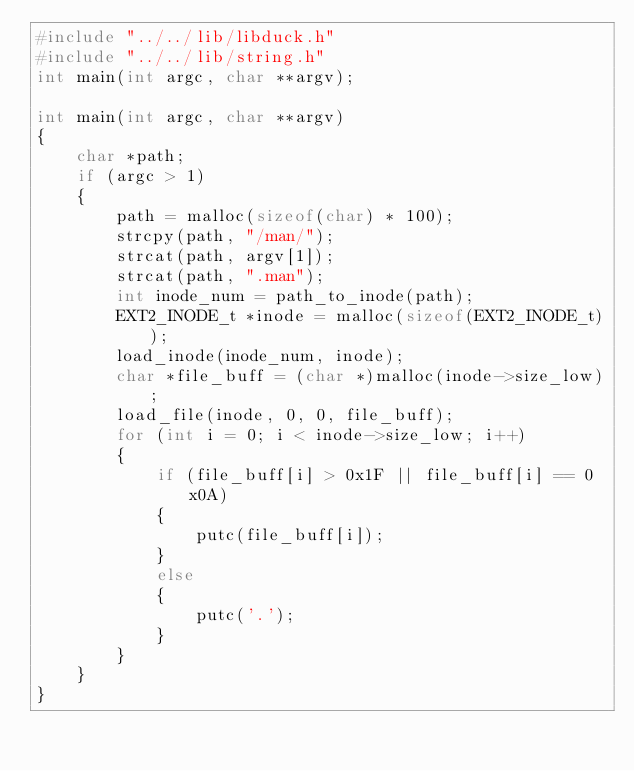<code> <loc_0><loc_0><loc_500><loc_500><_C_>#include "../../lib/libduck.h"
#include "../../lib/string.h"
int main(int argc, char **argv);

int main(int argc, char **argv)
{
    char *path;
    if (argc > 1)
    {
        path = malloc(sizeof(char) * 100);
        strcpy(path, "/man/");
        strcat(path, argv[1]);
        strcat(path, ".man");
        int inode_num = path_to_inode(path);
        EXT2_INODE_t *inode = malloc(sizeof(EXT2_INODE_t));
        load_inode(inode_num, inode);
        char *file_buff = (char *)malloc(inode->size_low);
        load_file(inode, 0, 0, file_buff);
        for (int i = 0; i < inode->size_low; i++)
        {
            if (file_buff[i] > 0x1F || file_buff[i] == 0x0A)
            {
                putc(file_buff[i]);
            }
            else
            {
                putc('.');
            }
        }
    }
}</code> 